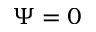<formula> <loc_0><loc_0><loc_500><loc_500>\Psi = 0</formula> 